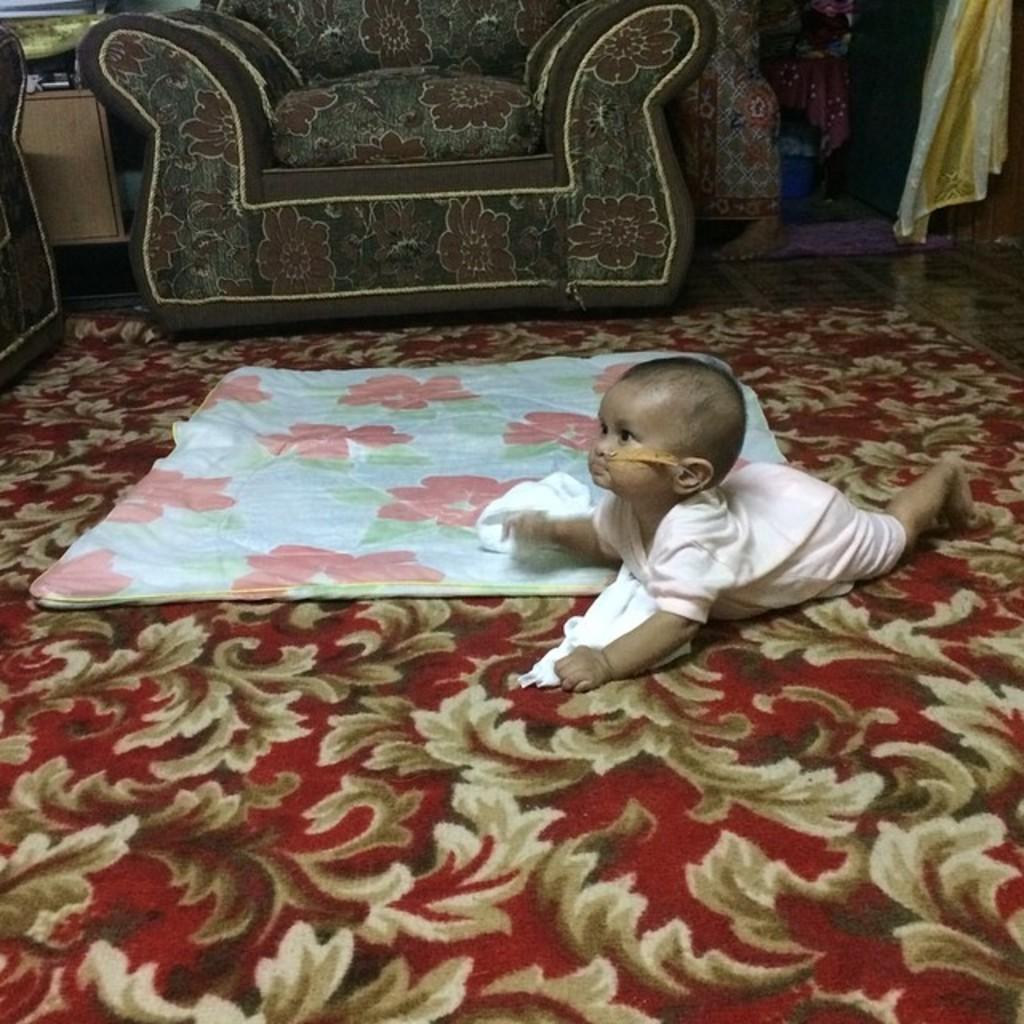How would you summarize this image in a sentence or two? In this image i can see a baby in a pink dress is crawling on the floor, and i can see a floor mat and the baby bed. In the background i can see a couch and few clothes. 